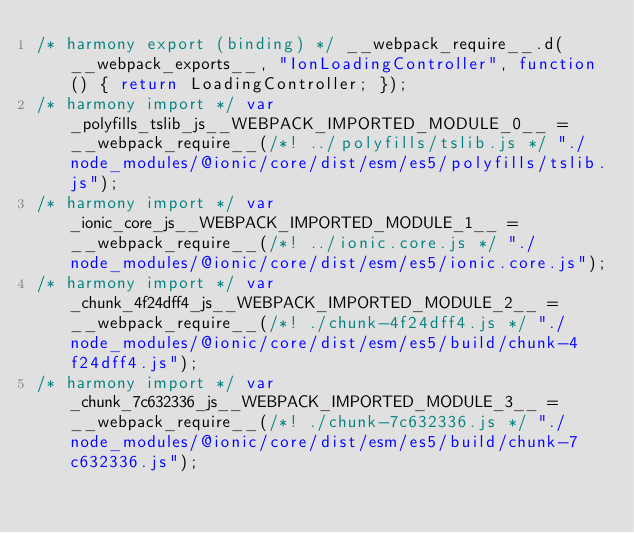<code> <loc_0><loc_0><loc_500><loc_500><_JavaScript_>/* harmony export (binding) */ __webpack_require__.d(__webpack_exports__, "IonLoadingController", function() { return LoadingController; });
/* harmony import */ var _polyfills_tslib_js__WEBPACK_IMPORTED_MODULE_0__ = __webpack_require__(/*! ../polyfills/tslib.js */ "./node_modules/@ionic/core/dist/esm/es5/polyfills/tslib.js");
/* harmony import */ var _ionic_core_js__WEBPACK_IMPORTED_MODULE_1__ = __webpack_require__(/*! ../ionic.core.js */ "./node_modules/@ionic/core/dist/esm/es5/ionic.core.js");
/* harmony import */ var _chunk_4f24dff4_js__WEBPACK_IMPORTED_MODULE_2__ = __webpack_require__(/*! ./chunk-4f24dff4.js */ "./node_modules/@ionic/core/dist/esm/es5/build/chunk-4f24dff4.js");
/* harmony import */ var _chunk_7c632336_js__WEBPACK_IMPORTED_MODULE_3__ = __webpack_require__(/*! ./chunk-7c632336.js */ "./node_modules/@ionic/core/dist/esm/es5/build/chunk-7c632336.js");</code> 